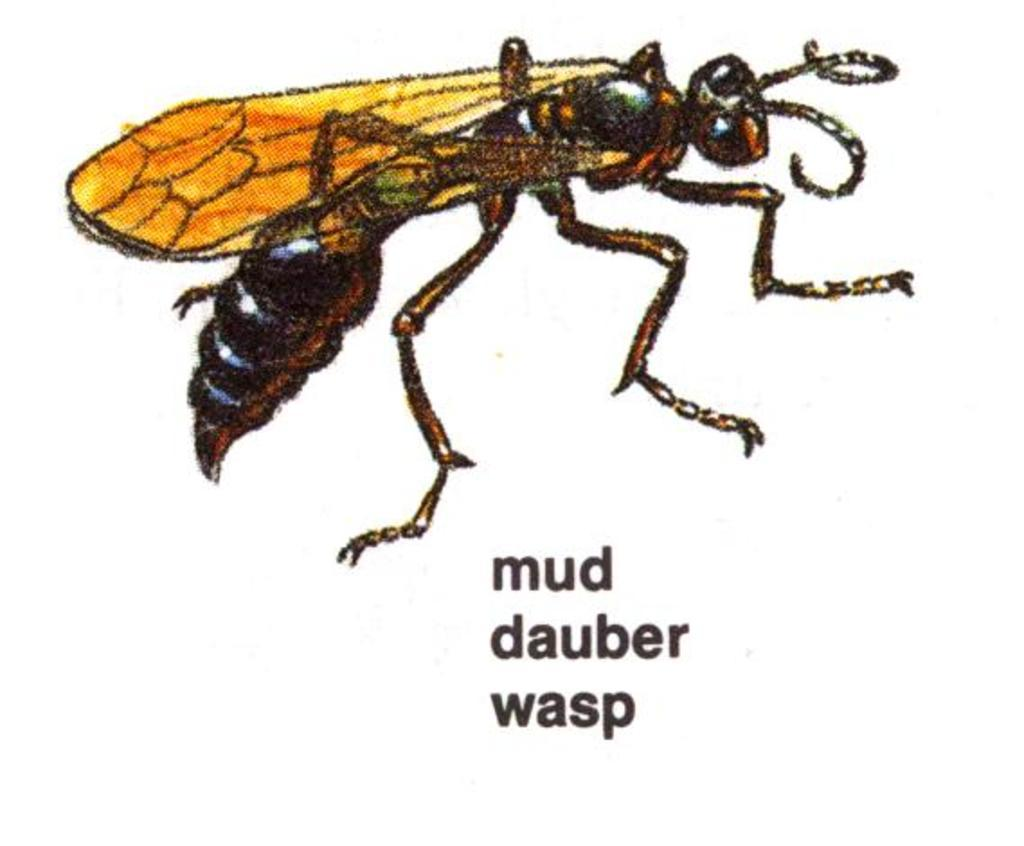What is depicted in the drawing in the image? There is a drawing of a fly in the image. What color is the background of the image? The background of the image is white. What can be found at the bottom of the image? There is text at the bottom of the image. What type of throne is depicted in the image? There is no throne present in the image; it features a drawing of a fly and text on a white background. What items are listed in the image? There is no list present in the image; it contains a drawing of a fly, a white background, and text at the bottom. 